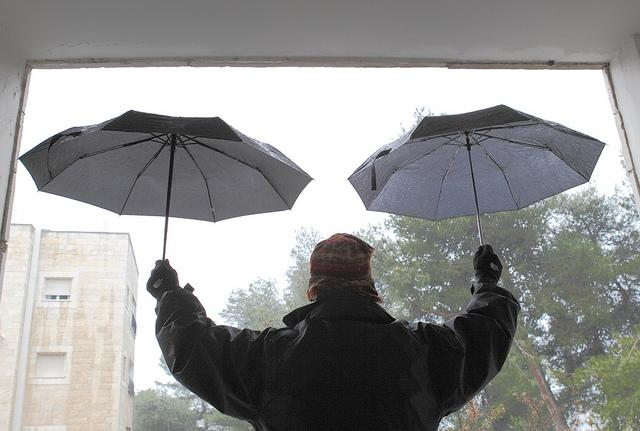Why does the man hold 2 umbrellas?

Choices:
A) sun protection
B) confusion
C) photograph pose
D) snow prevention photograph pose 